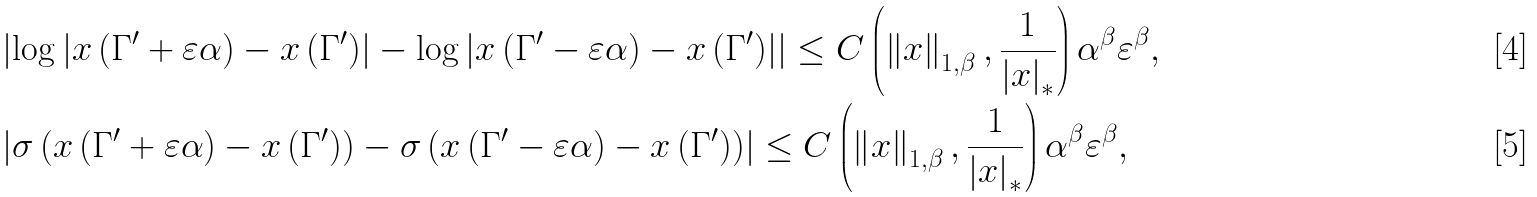Convert formula to latex. <formula><loc_0><loc_0><loc_500><loc_500>& \left | \log \left | x \left ( \Gamma ^ { \prime } + \varepsilon \alpha \right ) - x \left ( \Gamma ^ { \prime } \right ) \right | - \log \left | x \left ( \Gamma ^ { \prime } - \varepsilon \alpha \right ) - x \left ( \Gamma ^ { \prime } \right ) \right | \right | \leq C \left ( \left \| x \right \| _ { 1 , \beta } , \frac { 1 } { \left | x \right | _ { \ast } } \right ) \alpha ^ { \beta } \varepsilon ^ { \beta } , \\ & \left | \sigma \left ( x \left ( \Gamma ^ { \prime } + \varepsilon \alpha \right ) - x \left ( \Gamma ^ { \prime } \right ) \right ) - \sigma \left ( x \left ( \Gamma ^ { \prime } - \varepsilon \alpha \right ) - x \left ( \Gamma ^ { \prime } \right ) \right ) \right | \leq C \left ( \left \| x \right \| _ { 1 , \beta } , \frac { 1 } { \left | x \right | _ { \ast } } \right ) \alpha ^ { \beta } \varepsilon ^ { \beta } ,</formula> 